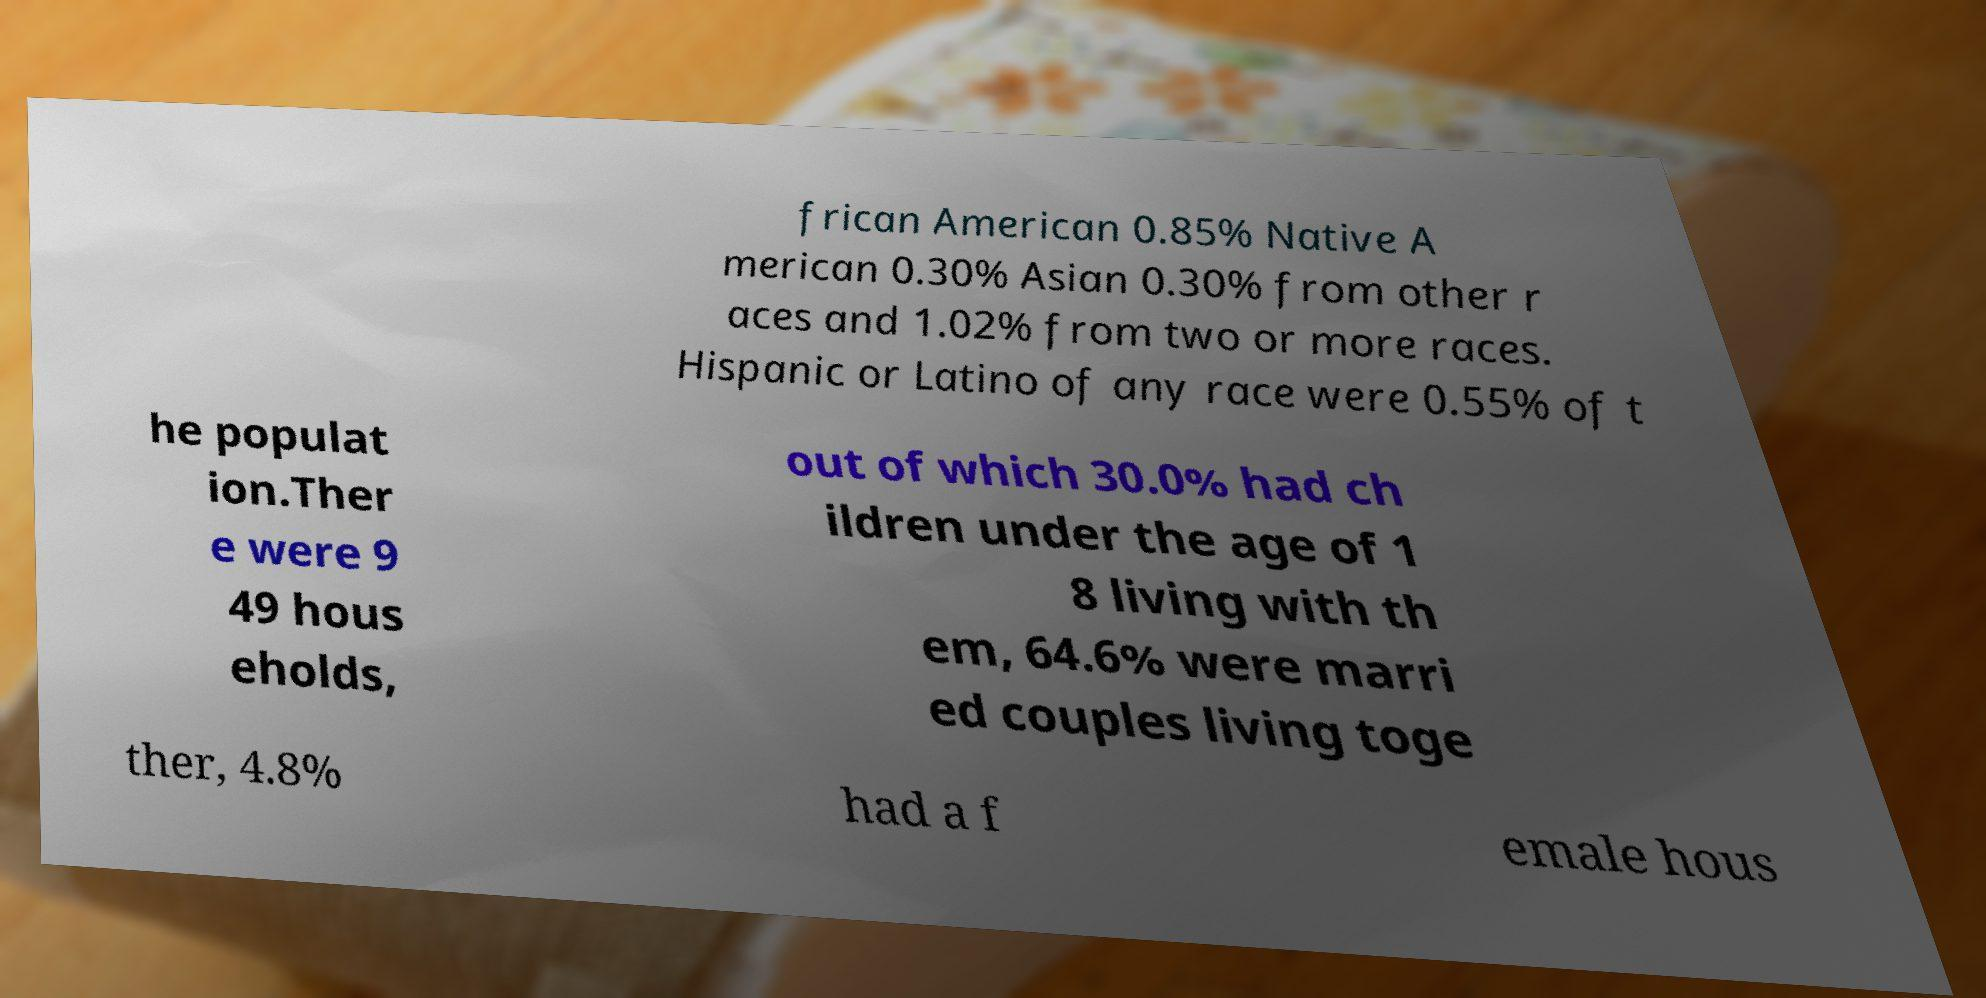Please identify and transcribe the text found in this image. frican American 0.85% Native A merican 0.30% Asian 0.30% from other r aces and 1.02% from two or more races. Hispanic or Latino of any race were 0.55% of t he populat ion.Ther e were 9 49 hous eholds, out of which 30.0% had ch ildren under the age of 1 8 living with th em, 64.6% were marri ed couples living toge ther, 4.8% had a f emale hous 